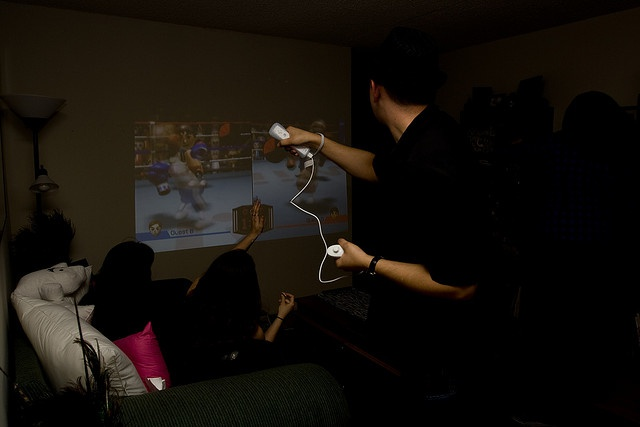Describe the objects in this image and their specific colors. I can see people in black, maroon, and brown tones, tv in black and gray tones, couch in black and gray tones, couch in black and gray tones, and people in black, maroon, and gray tones in this image. 